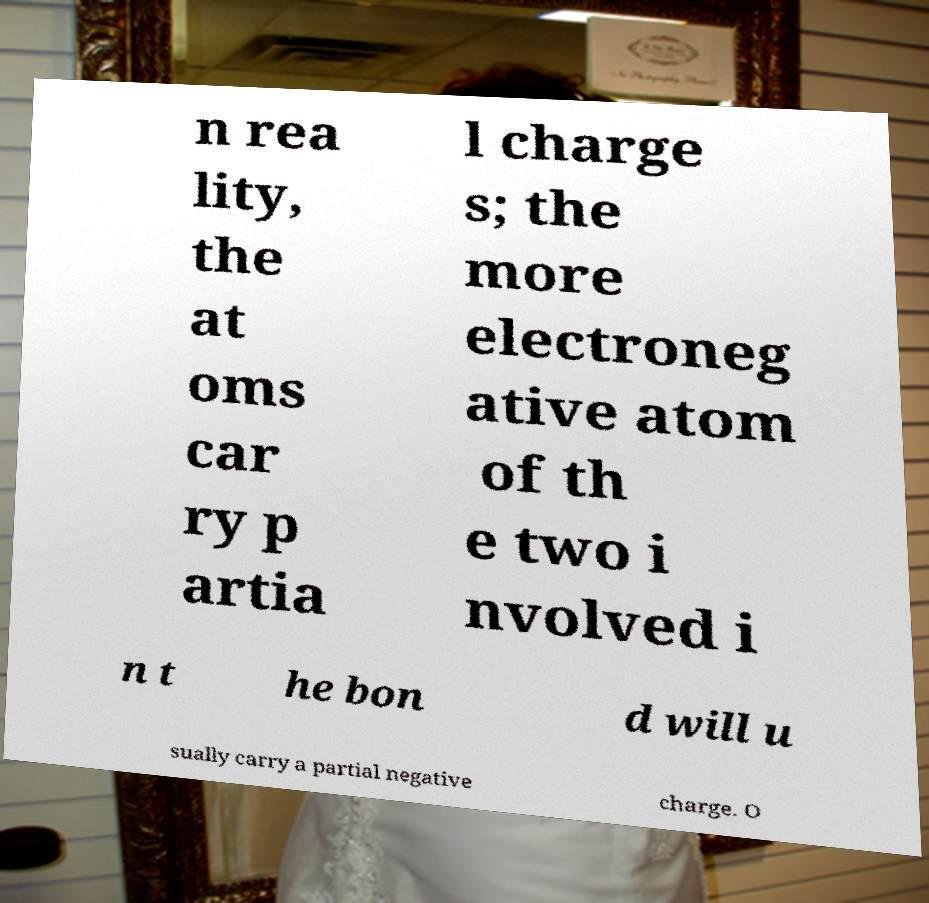For documentation purposes, I need the text within this image transcribed. Could you provide that? n rea lity, the at oms car ry p artia l charge s; the more electroneg ative atom of th e two i nvolved i n t he bon d will u sually carry a partial negative charge. O 